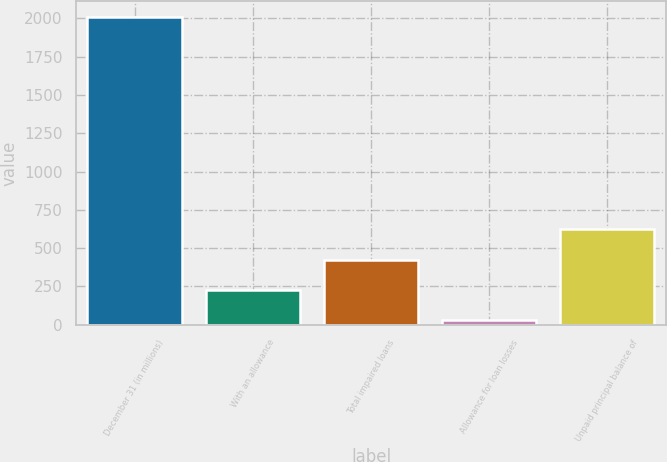Convert chart. <chart><loc_0><loc_0><loc_500><loc_500><bar_chart><fcel>December 31 (in millions)<fcel>With an allowance<fcel>Total impaired loans<fcel>Allowance for loan losses<fcel>Unpaid principal balance of<nl><fcel>2009<fcel>227.9<fcel>425.8<fcel>30<fcel>623.7<nl></chart> 